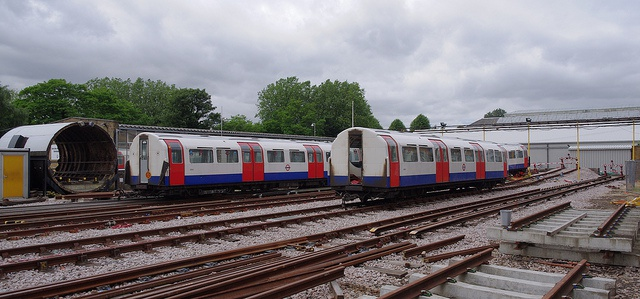Describe the objects in this image and their specific colors. I can see train in darkgray, black, gray, and navy tones and train in darkgray, black, gray, and navy tones in this image. 